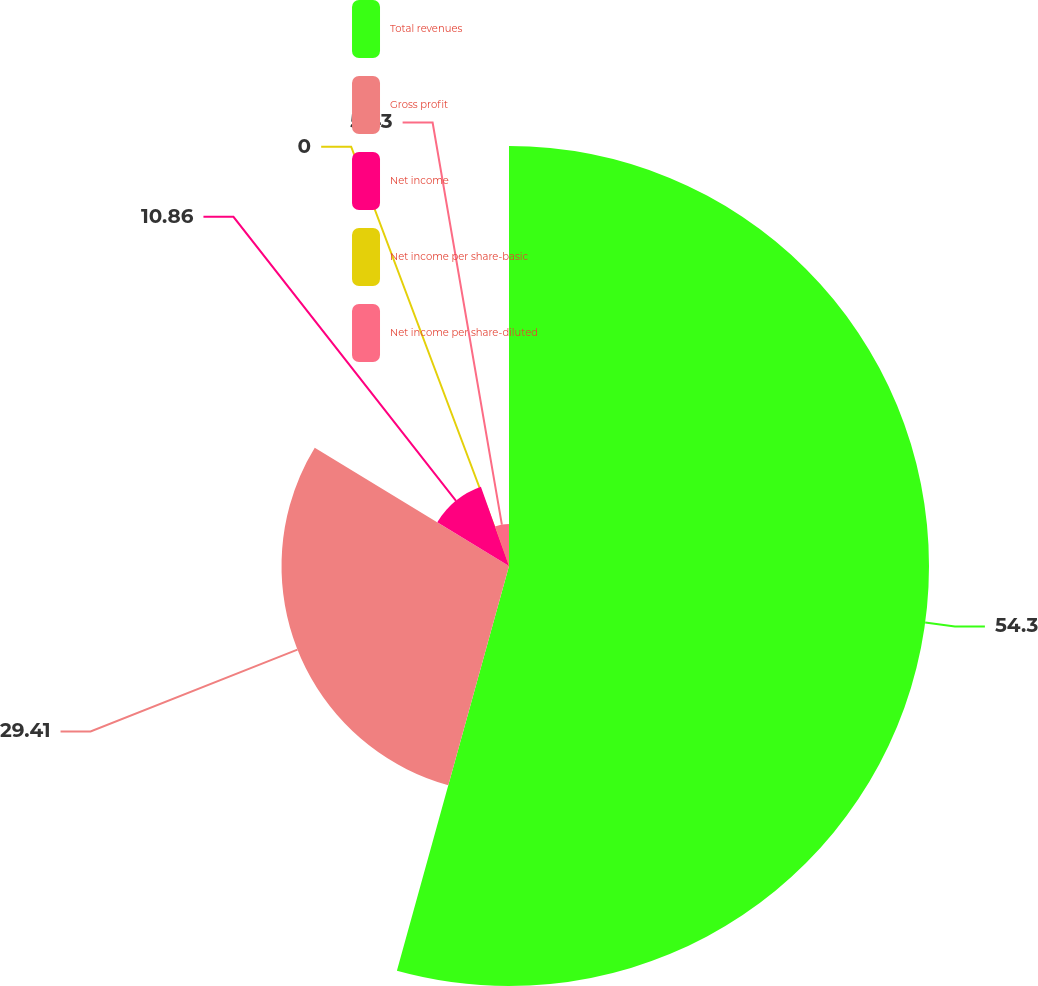Convert chart to OTSL. <chart><loc_0><loc_0><loc_500><loc_500><pie_chart><fcel>Total revenues<fcel>Gross profit<fcel>Net income<fcel>Net income per share-basic<fcel>Net income per share-diluted<nl><fcel>54.3%<fcel>29.41%<fcel>10.86%<fcel>0.0%<fcel>5.43%<nl></chart> 